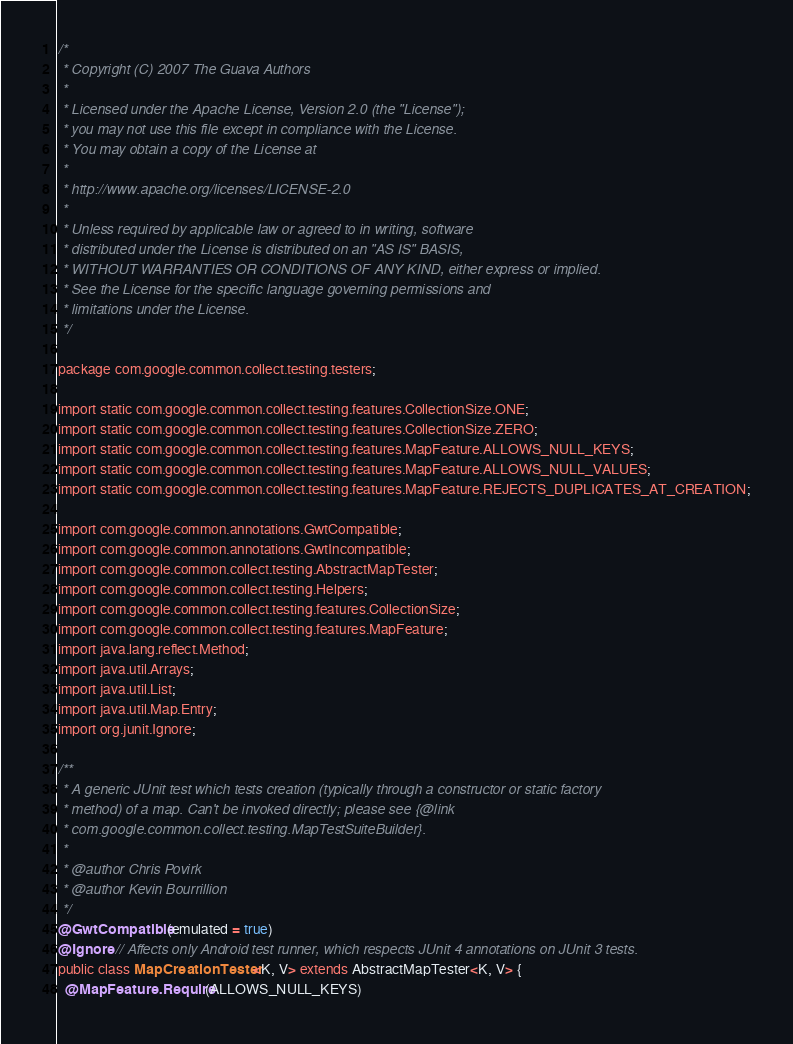Convert code to text. <code><loc_0><loc_0><loc_500><loc_500><_Java_>/*
 * Copyright (C) 2007 The Guava Authors
 *
 * Licensed under the Apache License, Version 2.0 (the "License");
 * you may not use this file except in compliance with the License.
 * You may obtain a copy of the License at
 *
 * http://www.apache.org/licenses/LICENSE-2.0
 *
 * Unless required by applicable law or agreed to in writing, software
 * distributed under the License is distributed on an "AS IS" BASIS,
 * WITHOUT WARRANTIES OR CONDITIONS OF ANY KIND, either express or implied.
 * See the License for the specific language governing permissions and
 * limitations under the License.
 */

package com.google.common.collect.testing.testers;

import static com.google.common.collect.testing.features.CollectionSize.ONE;
import static com.google.common.collect.testing.features.CollectionSize.ZERO;
import static com.google.common.collect.testing.features.MapFeature.ALLOWS_NULL_KEYS;
import static com.google.common.collect.testing.features.MapFeature.ALLOWS_NULL_VALUES;
import static com.google.common.collect.testing.features.MapFeature.REJECTS_DUPLICATES_AT_CREATION;

import com.google.common.annotations.GwtCompatible;
import com.google.common.annotations.GwtIncompatible;
import com.google.common.collect.testing.AbstractMapTester;
import com.google.common.collect.testing.Helpers;
import com.google.common.collect.testing.features.CollectionSize;
import com.google.common.collect.testing.features.MapFeature;
import java.lang.reflect.Method;
import java.util.Arrays;
import java.util.List;
import java.util.Map.Entry;
import org.junit.Ignore;

/**
 * A generic JUnit test which tests creation (typically through a constructor or static factory
 * method) of a map. Can't be invoked directly; please see {@link
 * com.google.common.collect.testing.MapTestSuiteBuilder}.
 *
 * @author Chris Povirk
 * @author Kevin Bourrillion
 */
@GwtCompatible(emulated = true)
@Ignore // Affects only Android test runner, which respects JUnit 4 annotations on JUnit 3 tests.
public class MapCreationTester<K, V> extends AbstractMapTester<K, V> {
  @MapFeature.Require(ALLOWS_NULL_KEYS)</code> 